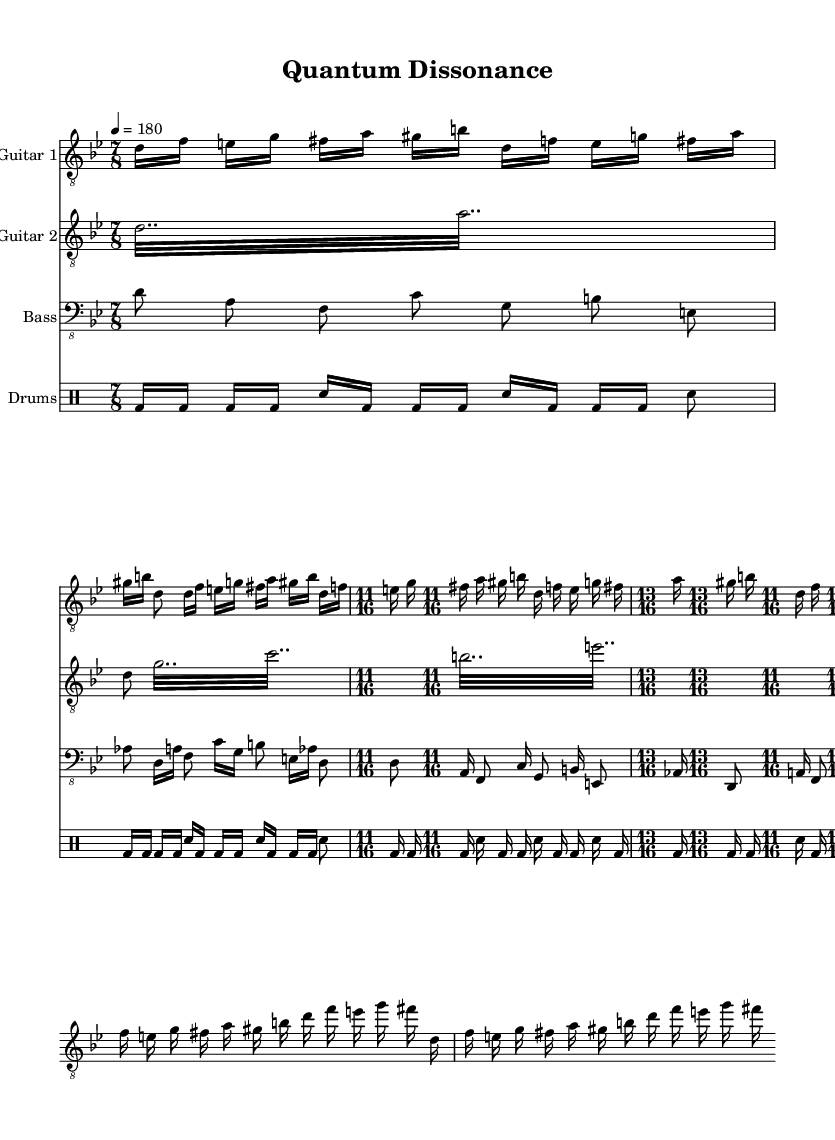What is the title of this piece? The title of the piece is indicated in the header section of the sheet music as "Quantum Dissonance".
Answer: Quantum Dissonance What is the tempo indicated for this piece? The tempo is specified in the global context with a metronome marking of "4 = 180", which means there are 180 beats per minute.
Answer: 180 What is the time signature used in the guitar parts? The first guitar has multiple time signatures, starting with 7/8, then 11/16, and finally 13/16. Each section uses different complex time signatures, highlighting technicality.
Answer: 7/8, 11/16, 13/16 What is the clef used for the bass part? The bass part is indicated with the clef name "bass_8", meaning it uses a bass clef notation for music notation commonly used for lower sounding instruments.
Answer: Bass How many beats are in the time signature of the opening section for Guitar 1? The opening section of Guitar 1 starts with a time signature of 7/8, which means there are 7 beats in each measure with each beat being one-eighth note.
Answer: 7 Which instrument features tremolo playing in this sheet music? The second guitar part is the one that features tremolo playing indicated by the word "tremolo" before the notes, showing rapid alternation of two pitches.
Answer: Guitar 2 What type of musical technique is prevalent in the drum part? The drum part showcases a combination of bass drum and snare hits, employing rhythmic variation characteristic of metal music, with setups like “bd” for bass drum and “sn” for snare in various time signatures.
Answer: Pitched rhythm variation 